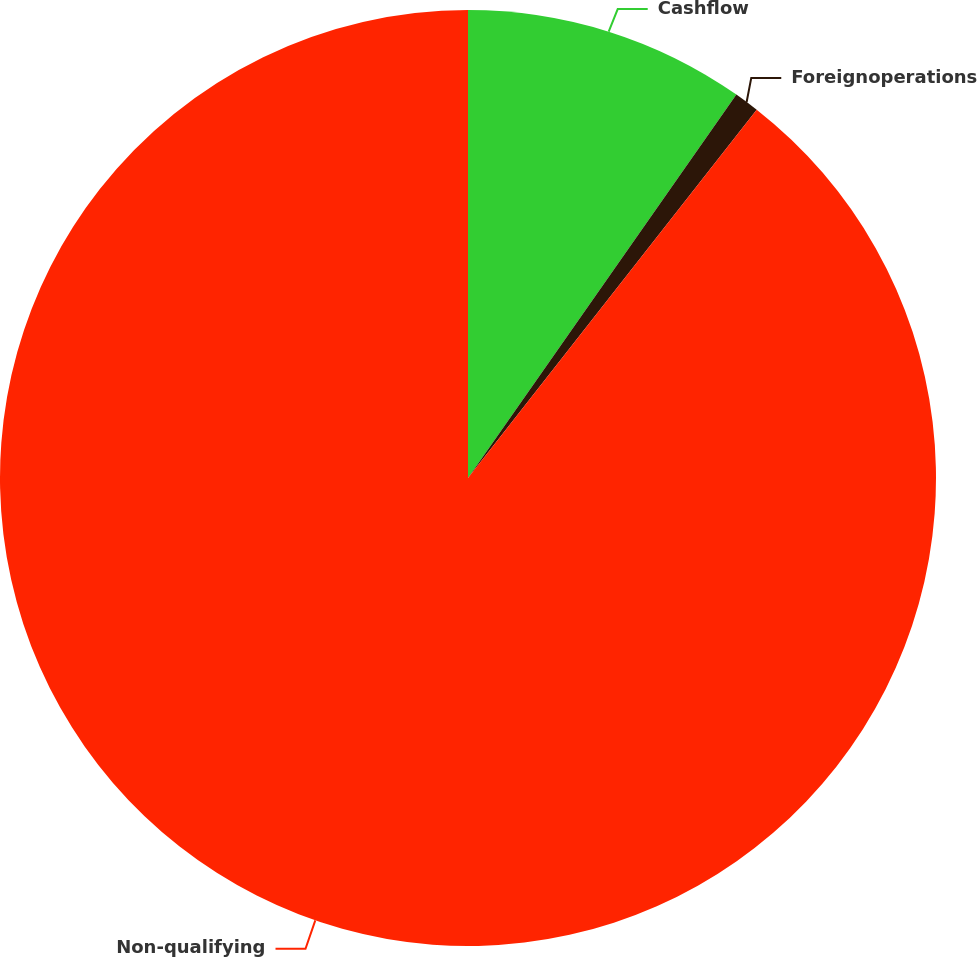<chart> <loc_0><loc_0><loc_500><loc_500><pie_chart><fcel>Cashflow<fcel>Foreignoperations<fcel>Non-qualifying<nl><fcel>9.72%<fcel>0.86%<fcel>89.42%<nl></chart> 